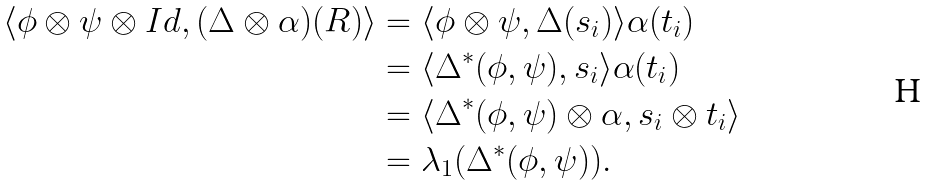<formula> <loc_0><loc_0><loc_500><loc_500>\langle \phi \otimes \psi \otimes I d , ( \Delta \otimes \alpha ) ( R ) \rangle & = \langle \phi \otimes \psi , \Delta ( s _ { i } ) \rangle \alpha ( t _ { i } ) \\ & = \langle \Delta ^ { * } ( \phi , \psi ) , s _ { i } \rangle \alpha ( t _ { i } ) \\ & = \langle \Delta ^ { * } ( \phi , \psi ) \otimes \alpha , s _ { i } \otimes t _ { i } \rangle \\ & = \lambda _ { 1 } ( \Delta ^ { * } ( \phi , \psi ) ) .</formula> 